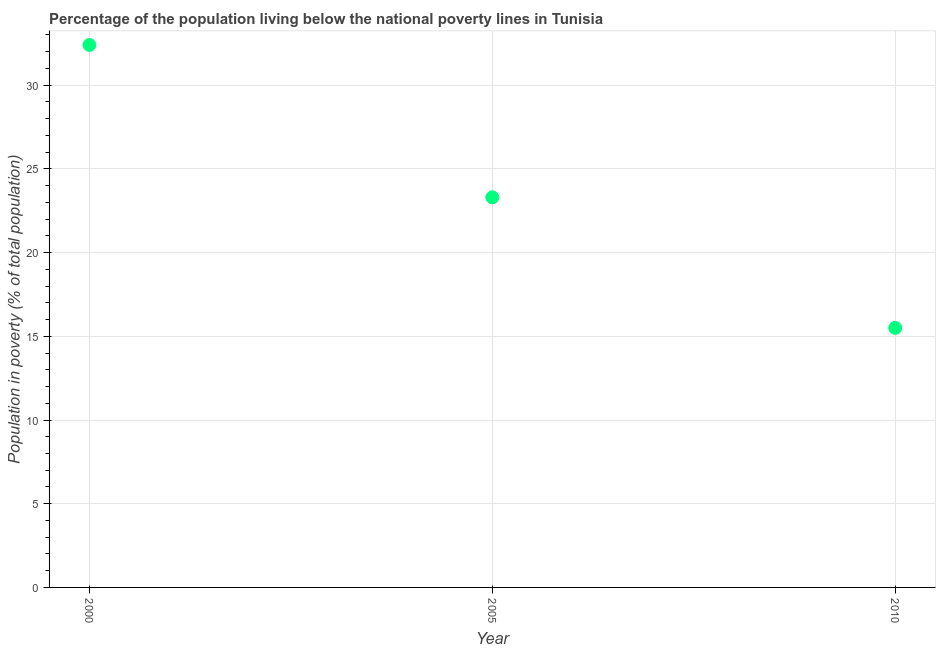Across all years, what is the maximum percentage of population living below poverty line?
Provide a short and direct response. 32.4. Across all years, what is the minimum percentage of population living below poverty line?
Offer a very short reply. 15.5. In which year was the percentage of population living below poverty line maximum?
Keep it short and to the point. 2000. What is the sum of the percentage of population living below poverty line?
Your answer should be very brief. 71.2. What is the difference between the percentage of population living below poverty line in 2000 and 2005?
Ensure brevity in your answer.  9.1. What is the average percentage of population living below poverty line per year?
Your answer should be compact. 23.73. What is the median percentage of population living below poverty line?
Ensure brevity in your answer.  23.3. In how many years, is the percentage of population living below poverty line greater than 20 %?
Give a very brief answer. 2. Do a majority of the years between 2000 and 2010 (inclusive) have percentage of population living below poverty line greater than 7 %?
Ensure brevity in your answer.  Yes. What is the ratio of the percentage of population living below poverty line in 2005 to that in 2010?
Your answer should be very brief. 1.5. What is the difference between the highest and the second highest percentage of population living below poverty line?
Your answer should be very brief. 9.1. Is the sum of the percentage of population living below poverty line in 2000 and 2010 greater than the maximum percentage of population living below poverty line across all years?
Offer a terse response. Yes. What is the difference between the highest and the lowest percentage of population living below poverty line?
Your answer should be compact. 16.9. In how many years, is the percentage of population living below poverty line greater than the average percentage of population living below poverty line taken over all years?
Offer a terse response. 1. Does the percentage of population living below poverty line monotonically increase over the years?
Your answer should be very brief. No. How many years are there in the graph?
Your answer should be very brief. 3. What is the difference between two consecutive major ticks on the Y-axis?
Keep it short and to the point. 5. Are the values on the major ticks of Y-axis written in scientific E-notation?
Give a very brief answer. No. Does the graph contain any zero values?
Offer a very short reply. No. What is the title of the graph?
Offer a very short reply. Percentage of the population living below the national poverty lines in Tunisia. What is the label or title of the Y-axis?
Your answer should be compact. Population in poverty (% of total population). What is the Population in poverty (% of total population) in 2000?
Ensure brevity in your answer.  32.4. What is the Population in poverty (% of total population) in 2005?
Your response must be concise. 23.3. What is the difference between the Population in poverty (% of total population) in 2000 and 2005?
Your answer should be very brief. 9.1. What is the difference between the Population in poverty (% of total population) in 2000 and 2010?
Offer a terse response. 16.9. What is the ratio of the Population in poverty (% of total population) in 2000 to that in 2005?
Ensure brevity in your answer.  1.39. What is the ratio of the Population in poverty (% of total population) in 2000 to that in 2010?
Your answer should be compact. 2.09. What is the ratio of the Population in poverty (% of total population) in 2005 to that in 2010?
Offer a very short reply. 1.5. 